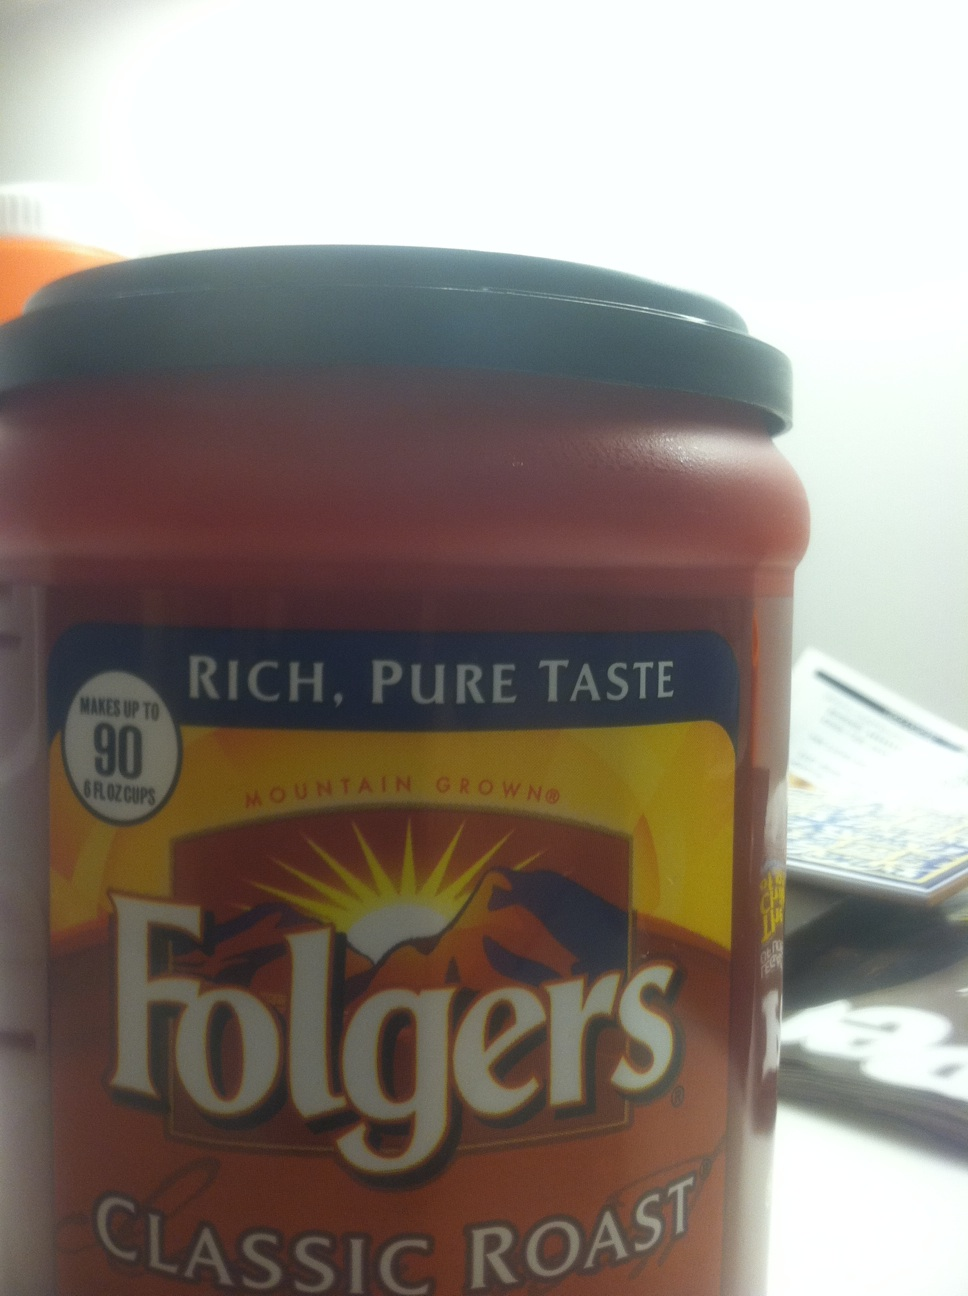Can you tell me more about the flavor profile of Folgers Classic Roast coffee? Certainly! Folgers Classic Roast coffee is known for its smooth and mellow flavor. It is a medium roast, which typically offers a balanced taste with notes of caramel and a slightly acidic finish. It's a well-rounded blend that appeals to a wide range of coffee drinkers. 